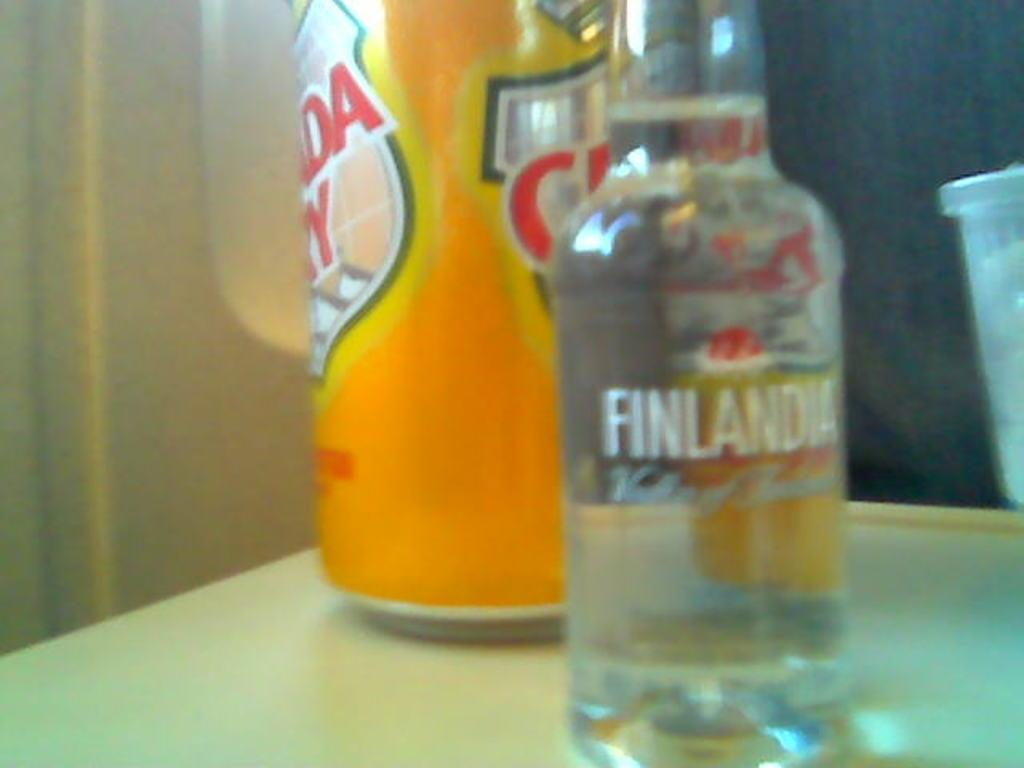What is the main object in the image? There is a table in the image. What is on the table? There is a bottle on the table. Can you describe the bottle? The bottle has a sticker. How much dirt is visible on the chair in the image? There is no chair present in the image, so it is not possible to determine how much dirt might be visible on it. 